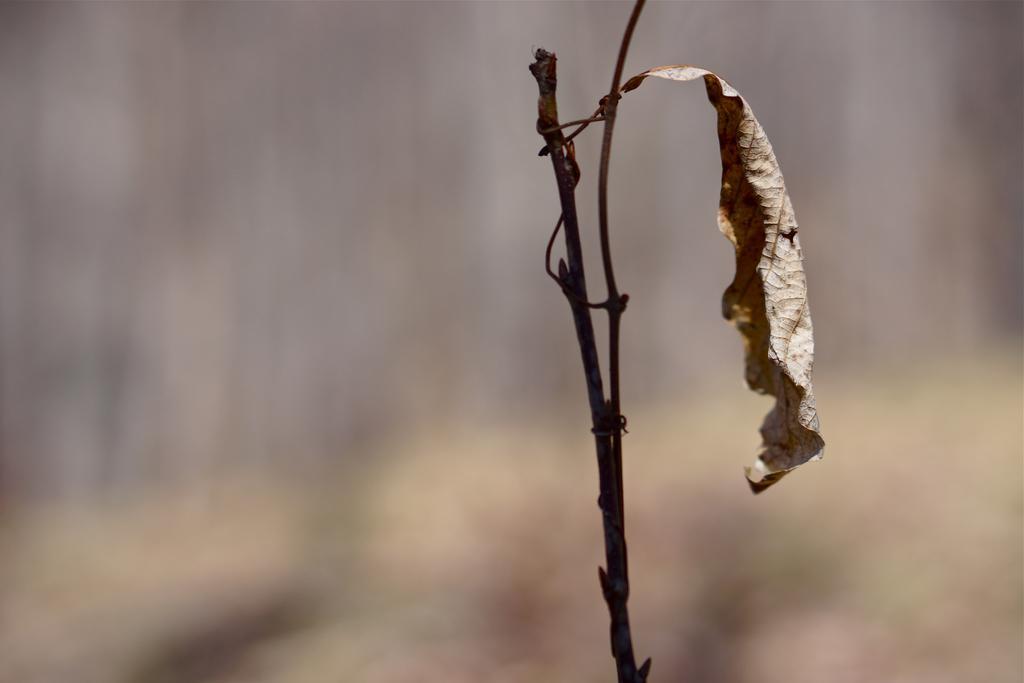Please provide a concise description of this image. In the center of the image we can see a dry leaf with stem. In the background the image is blur. 